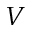<formula> <loc_0><loc_0><loc_500><loc_500>V</formula> 